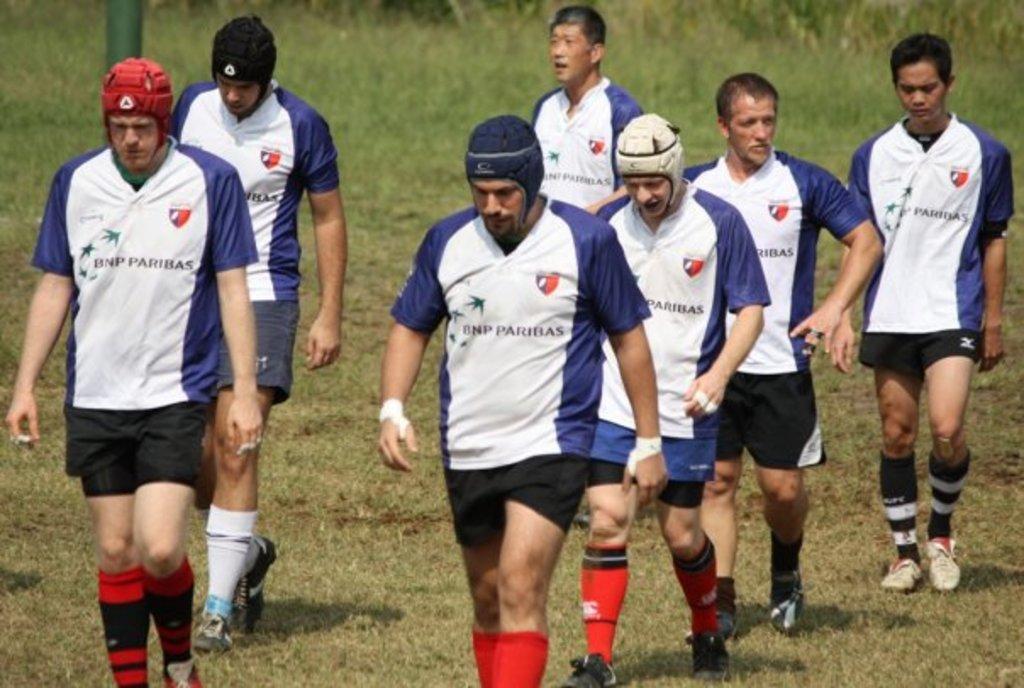In one or two sentences, can you explain what this image depicts? In the image we can see there are people walking, wearing clothes, socks, shoes and some of them are wearing caps. Here we can see the grass and the pole. 